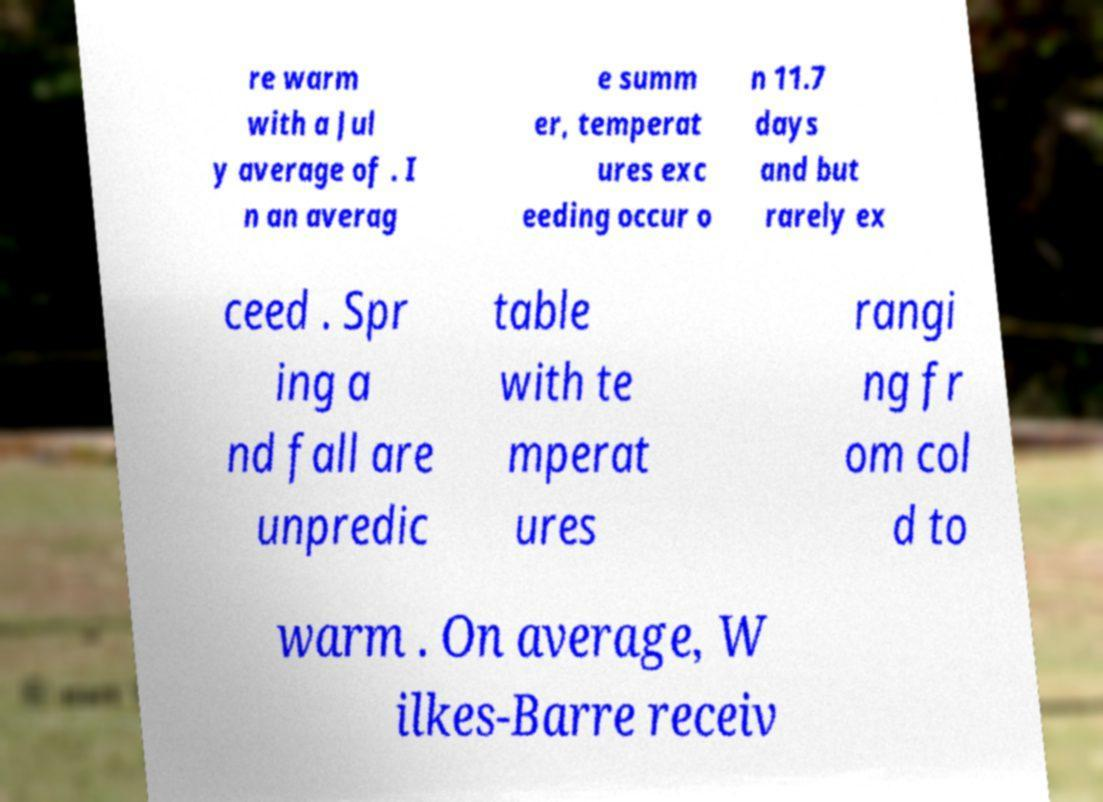Please read and relay the text visible in this image. What does it say? re warm with a Jul y average of . I n an averag e summ er, temperat ures exc eeding occur o n 11.7 days and but rarely ex ceed . Spr ing a nd fall are unpredic table with te mperat ures rangi ng fr om col d to warm . On average, W ilkes-Barre receiv 